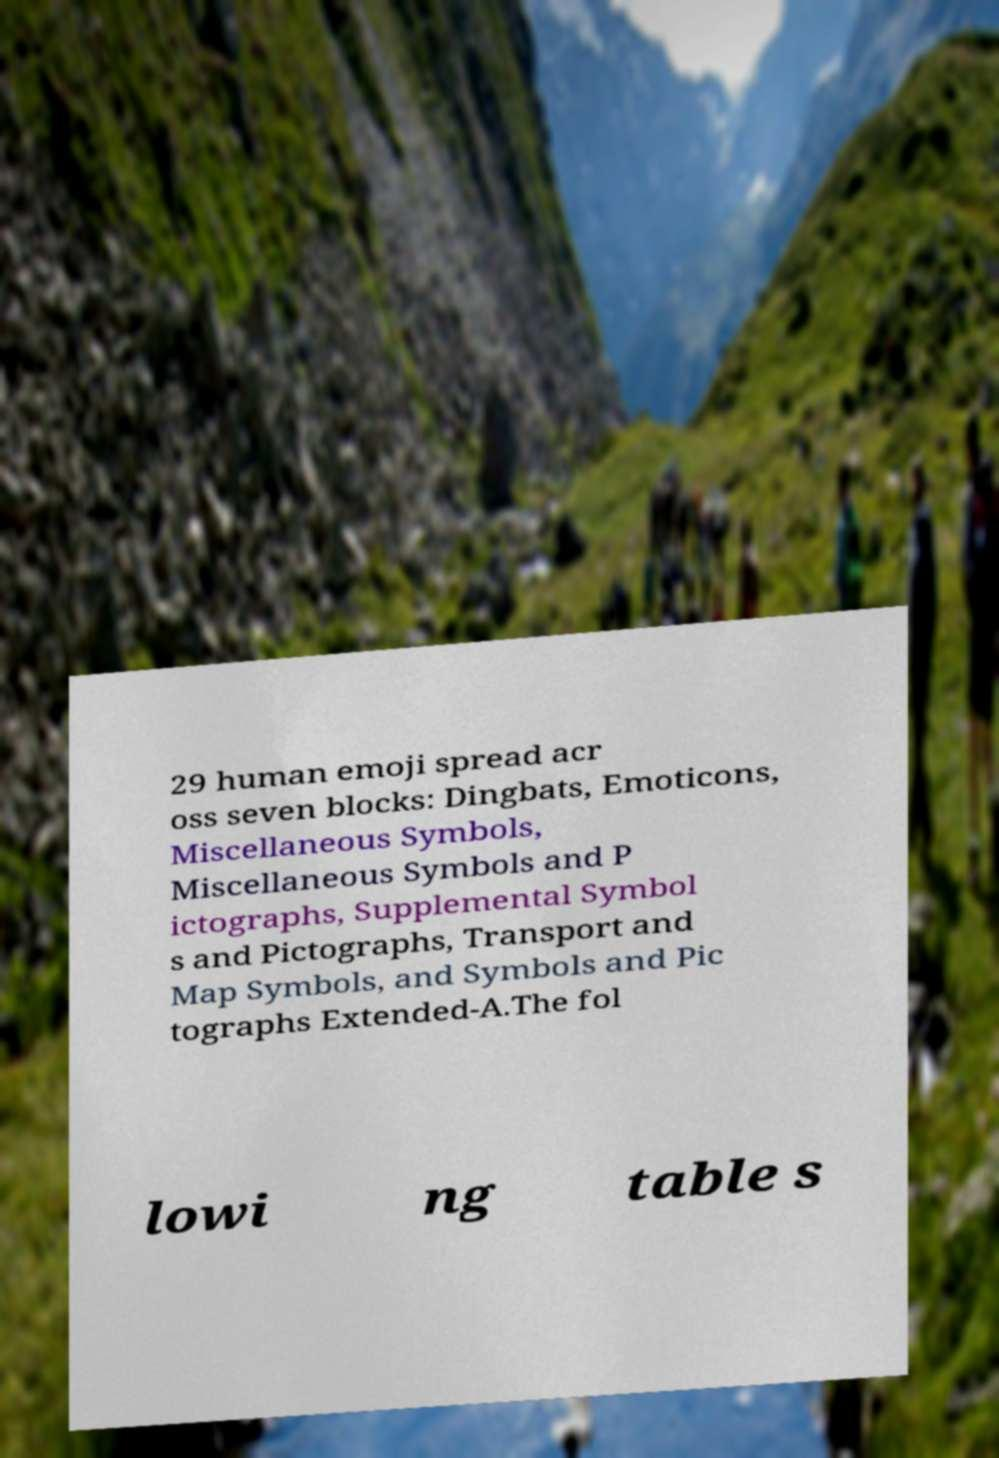Please identify and transcribe the text found in this image. 29 human emoji spread acr oss seven blocks: Dingbats, Emoticons, Miscellaneous Symbols, Miscellaneous Symbols and P ictographs, Supplemental Symbol s and Pictographs, Transport and Map Symbols, and Symbols and Pic tographs Extended-A.The fol lowi ng table s 